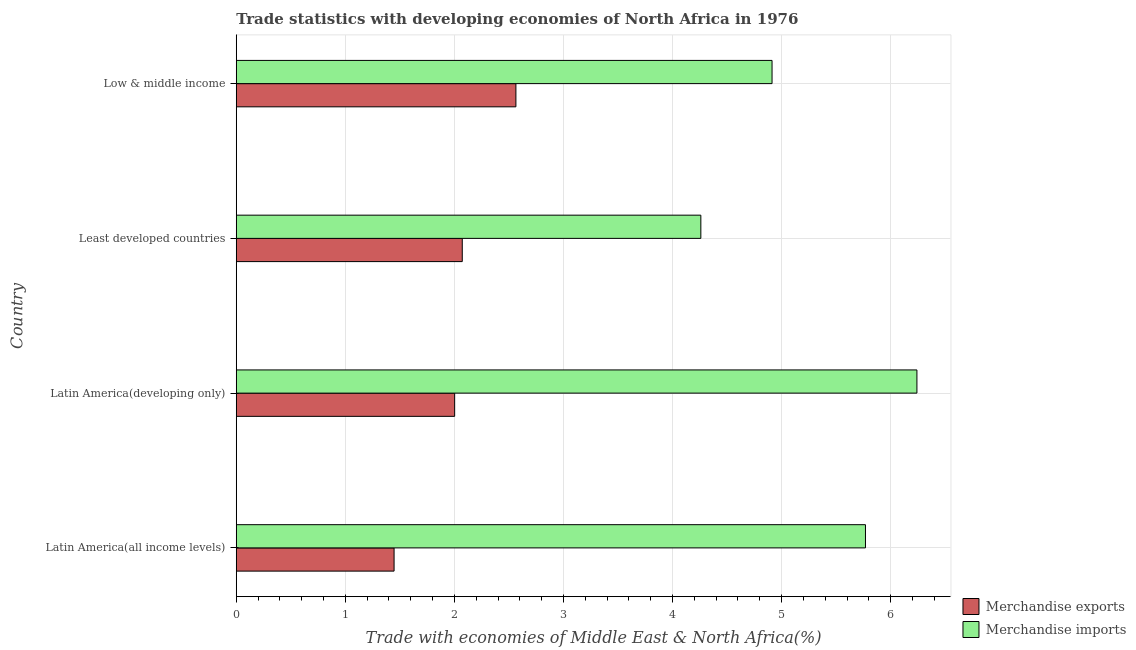How many different coloured bars are there?
Offer a terse response. 2. How many groups of bars are there?
Make the answer very short. 4. Are the number of bars per tick equal to the number of legend labels?
Your answer should be compact. Yes. How many bars are there on the 2nd tick from the top?
Provide a succinct answer. 2. What is the label of the 3rd group of bars from the top?
Ensure brevity in your answer.  Latin America(developing only). What is the merchandise exports in Latin America(all income levels)?
Ensure brevity in your answer.  1.45. Across all countries, what is the maximum merchandise exports?
Keep it short and to the point. 2.56. Across all countries, what is the minimum merchandise exports?
Your response must be concise. 1.45. In which country was the merchandise imports maximum?
Offer a terse response. Latin America(developing only). In which country was the merchandise exports minimum?
Make the answer very short. Latin America(all income levels). What is the total merchandise exports in the graph?
Make the answer very short. 8.09. What is the difference between the merchandise imports in Latin America(all income levels) and that in Latin America(developing only)?
Give a very brief answer. -0.47. What is the difference between the merchandise exports in Low & middle income and the merchandise imports in Latin America(all income levels)?
Offer a very short reply. -3.21. What is the average merchandise imports per country?
Your answer should be very brief. 5.3. What is the difference between the merchandise imports and merchandise exports in Latin America(all income levels)?
Make the answer very short. 4.32. What is the ratio of the merchandise imports in Latin America(all income levels) to that in Low & middle income?
Provide a succinct answer. 1.17. Is the merchandise imports in Latin America(all income levels) less than that in Latin America(developing only)?
Your response must be concise. Yes. Is the difference between the merchandise imports in Latin America(developing only) and Least developed countries greater than the difference between the merchandise exports in Latin America(developing only) and Least developed countries?
Keep it short and to the point. Yes. What is the difference between the highest and the second highest merchandise imports?
Ensure brevity in your answer.  0.47. What is the difference between the highest and the lowest merchandise imports?
Offer a very short reply. 1.98. Is the sum of the merchandise imports in Latin America(all income levels) and Low & middle income greater than the maximum merchandise exports across all countries?
Provide a short and direct response. Yes. What does the 2nd bar from the top in Low & middle income represents?
Make the answer very short. Merchandise exports. What does the 1st bar from the bottom in Latin America(all income levels) represents?
Your response must be concise. Merchandise exports. How many bars are there?
Provide a short and direct response. 8. Does the graph contain grids?
Keep it short and to the point. Yes. Where does the legend appear in the graph?
Offer a very short reply. Bottom right. How many legend labels are there?
Provide a short and direct response. 2. What is the title of the graph?
Offer a terse response. Trade statistics with developing economies of North Africa in 1976. What is the label or title of the X-axis?
Provide a succinct answer. Trade with economies of Middle East & North Africa(%). What is the Trade with economies of Middle East & North Africa(%) of Merchandise exports in Latin America(all income levels)?
Your answer should be very brief. 1.45. What is the Trade with economies of Middle East & North Africa(%) in Merchandise imports in Latin America(all income levels)?
Provide a succinct answer. 5.77. What is the Trade with economies of Middle East & North Africa(%) in Merchandise exports in Latin America(developing only)?
Provide a succinct answer. 2. What is the Trade with economies of Middle East & North Africa(%) in Merchandise imports in Latin America(developing only)?
Your response must be concise. 6.24. What is the Trade with economies of Middle East & North Africa(%) in Merchandise exports in Least developed countries?
Ensure brevity in your answer.  2.07. What is the Trade with economies of Middle East & North Africa(%) of Merchandise imports in Least developed countries?
Keep it short and to the point. 4.26. What is the Trade with economies of Middle East & North Africa(%) in Merchandise exports in Low & middle income?
Keep it short and to the point. 2.56. What is the Trade with economies of Middle East & North Africa(%) of Merchandise imports in Low & middle income?
Provide a succinct answer. 4.91. Across all countries, what is the maximum Trade with economies of Middle East & North Africa(%) in Merchandise exports?
Your response must be concise. 2.56. Across all countries, what is the maximum Trade with economies of Middle East & North Africa(%) in Merchandise imports?
Keep it short and to the point. 6.24. Across all countries, what is the minimum Trade with economies of Middle East & North Africa(%) of Merchandise exports?
Keep it short and to the point. 1.45. Across all countries, what is the minimum Trade with economies of Middle East & North Africa(%) in Merchandise imports?
Make the answer very short. 4.26. What is the total Trade with economies of Middle East & North Africa(%) of Merchandise exports in the graph?
Your answer should be compact. 8.09. What is the total Trade with economies of Middle East & North Africa(%) in Merchandise imports in the graph?
Keep it short and to the point. 21.18. What is the difference between the Trade with economies of Middle East & North Africa(%) in Merchandise exports in Latin America(all income levels) and that in Latin America(developing only)?
Offer a very short reply. -0.56. What is the difference between the Trade with economies of Middle East & North Africa(%) of Merchandise imports in Latin America(all income levels) and that in Latin America(developing only)?
Your answer should be very brief. -0.47. What is the difference between the Trade with economies of Middle East & North Africa(%) in Merchandise exports in Latin America(all income levels) and that in Least developed countries?
Keep it short and to the point. -0.63. What is the difference between the Trade with economies of Middle East & North Africa(%) of Merchandise imports in Latin America(all income levels) and that in Least developed countries?
Provide a succinct answer. 1.51. What is the difference between the Trade with economies of Middle East & North Africa(%) in Merchandise exports in Latin America(all income levels) and that in Low & middle income?
Make the answer very short. -1.12. What is the difference between the Trade with economies of Middle East & North Africa(%) of Merchandise imports in Latin America(all income levels) and that in Low & middle income?
Ensure brevity in your answer.  0.86. What is the difference between the Trade with economies of Middle East & North Africa(%) in Merchandise exports in Latin America(developing only) and that in Least developed countries?
Ensure brevity in your answer.  -0.07. What is the difference between the Trade with economies of Middle East & North Africa(%) in Merchandise imports in Latin America(developing only) and that in Least developed countries?
Provide a short and direct response. 1.98. What is the difference between the Trade with economies of Middle East & North Africa(%) in Merchandise exports in Latin America(developing only) and that in Low & middle income?
Your answer should be compact. -0.56. What is the difference between the Trade with economies of Middle East & North Africa(%) of Merchandise imports in Latin America(developing only) and that in Low & middle income?
Keep it short and to the point. 1.33. What is the difference between the Trade with economies of Middle East & North Africa(%) of Merchandise exports in Least developed countries and that in Low & middle income?
Offer a terse response. -0.49. What is the difference between the Trade with economies of Middle East & North Africa(%) of Merchandise imports in Least developed countries and that in Low & middle income?
Ensure brevity in your answer.  -0.65. What is the difference between the Trade with economies of Middle East & North Africa(%) of Merchandise exports in Latin America(all income levels) and the Trade with economies of Middle East & North Africa(%) of Merchandise imports in Latin America(developing only)?
Ensure brevity in your answer.  -4.79. What is the difference between the Trade with economies of Middle East & North Africa(%) of Merchandise exports in Latin America(all income levels) and the Trade with economies of Middle East & North Africa(%) of Merchandise imports in Least developed countries?
Keep it short and to the point. -2.81. What is the difference between the Trade with economies of Middle East & North Africa(%) in Merchandise exports in Latin America(all income levels) and the Trade with economies of Middle East & North Africa(%) in Merchandise imports in Low & middle income?
Your answer should be very brief. -3.47. What is the difference between the Trade with economies of Middle East & North Africa(%) in Merchandise exports in Latin America(developing only) and the Trade with economies of Middle East & North Africa(%) in Merchandise imports in Least developed countries?
Your answer should be very brief. -2.26. What is the difference between the Trade with economies of Middle East & North Africa(%) in Merchandise exports in Latin America(developing only) and the Trade with economies of Middle East & North Africa(%) in Merchandise imports in Low & middle income?
Offer a very short reply. -2.91. What is the difference between the Trade with economies of Middle East & North Africa(%) of Merchandise exports in Least developed countries and the Trade with economies of Middle East & North Africa(%) of Merchandise imports in Low & middle income?
Make the answer very short. -2.84. What is the average Trade with economies of Middle East & North Africa(%) in Merchandise exports per country?
Provide a succinct answer. 2.02. What is the average Trade with economies of Middle East & North Africa(%) in Merchandise imports per country?
Ensure brevity in your answer.  5.3. What is the difference between the Trade with economies of Middle East & North Africa(%) of Merchandise exports and Trade with economies of Middle East & North Africa(%) of Merchandise imports in Latin America(all income levels)?
Your response must be concise. -4.32. What is the difference between the Trade with economies of Middle East & North Africa(%) of Merchandise exports and Trade with economies of Middle East & North Africa(%) of Merchandise imports in Latin America(developing only)?
Your answer should be compact. -4.24. What is the difference between the Trade with economies of Middle East & North Africa(%) of Merchandise exports and Trade with economies of Middle East & North Africa(%) of Merchandise imports in Least developed countries?
Your answer should be very brief. -2.19. What is the difference between the Trade with economies of Middle East & North Africa(%) of Merchandise exports and Trade with economies of Middle East & North Africa(%) of Merchandise imports in Low & middle income?
Ensure brevity in your answer.  -2.35. What is the ratio of the Trade with economies of Middle East & North Africa(%) in Merchandise exports in Latin America(all income levels) to that in Latin America(developing only)?
Offer a very short reply. 0.72. What is the ratio of the Trade with economies of Middle East & North Africa(%) of Merchandise imports in Latin America(all income levels) to that in Latin America(developing only)?
Offer a terse response. 0.92. What is the ratio of the Trade with economies of Middle East & North Africa(%) in Merchandise exports in Latin America(all income levels) to that in Least developed countries?
Offer a terse response. 0.7. What is the ratio of the Trade with economies of Middle East & North Africa(%) of Merchandise imports in Latin America(all income levels) to that in Least developed countries?
Your answer should be very brief. 1.35. What is the ratio of the Trade with economies of Middle East & North Africa(%) of Merchandise exports in Latin America(all income levels) to that in Low & middle income?
Offer a very short reply. 0.56. What is the ratio of the Trade with economies of Middle East & North Africa(%) in Merchandise imports in Latin America(all income levels) to that in Low & middle income?
Provide a short and direct response. 1.17. What is the ratio of the Trade with economies of Middle East & North Africa(%) in Merchandise exports in Latin America(developing only) to that in Least developed countries?
Ensure brevity in your answer.  0.97. What is the ratio of the Trade with economies of Middle East & North Africa(%) of Merchandise imports in Latin America(developing only) to that in Least developed countries?
Offer a very short reply. 1.47. What is the ratio of the Trade with economies of Middle East & North Africa(%) of Merchandise exports in Latin America(developing only) to that in Low & middle income?
Provide a succinct answer. 0.78. What is the ratio of the Trade with economies of Middle East & North Africa(%) of Merchandise imports in Latin America(developing only) to that in Low & middle income?
Your answer should be compact. 1.27. What is the ratio of the Trade with economies of Middle East & North Africa(%) in Merchandise exports in Least developed countries to that in Low & middle income?
Give a very brief answer. 0.81. What is the ratio of the Trade with economies of Middle East & North Africa(%) of Merchandise imports in Least developed countries to that in Low & middle income?
Your answer should be very brief. 0.87. What is the difference between the highest and the second highest Trade with economies of Middle East & North Africa(%) of Merchandise exports?
Your answer should be very brief. 0.49. What is the difference between the highest and the second highest Trade with economies of Middle East & North Africa(%) of Merchandise imports?
Your response must be concise. 0.47. What is the difference between the highest and the lowest Trade with economies of Middle East & North Africa(%) of Merchandise exports?
Provide a short and direct response. 1.12. What is the difference between the highest and the lowest Trade with economies of Middle East & North Africa(%) of Merchandise imports?
Offer a terse response. 1.98. 